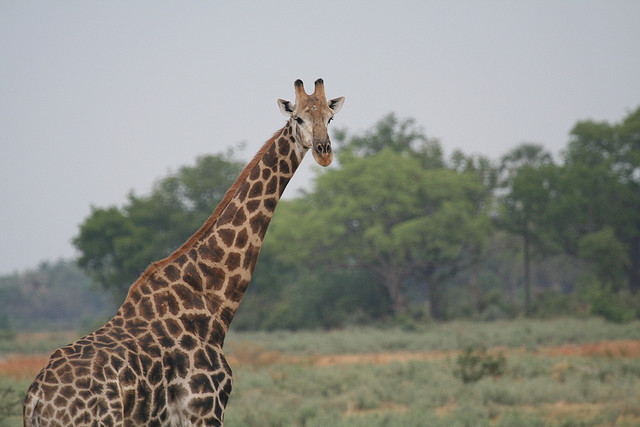<image>What kind of tree is to the right? It is ambiguous to answer what kind of tree is to the right. It could be oak, maple, poplar, elm, or acacia. What kind of tree is to the right? I don't know what kind of tree is to the right. It can be oak, maple, poplar, elm, or acacia. 